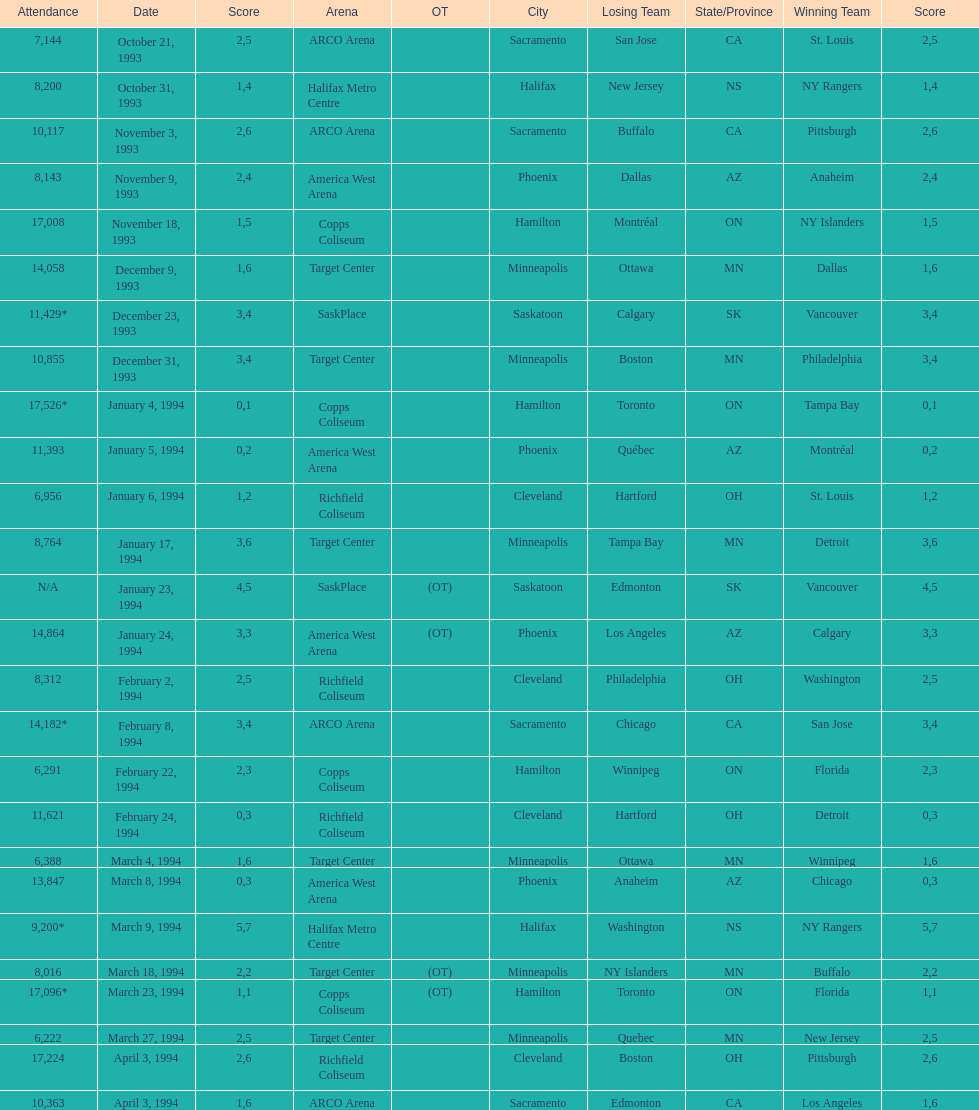Can you give me this table as a dict? {'header': ['Attendance', 'Date', 'Score', 'Arena', 'OT', 'City', 'Losing Team', 'State/Province', 'Winning Team', 'Score'], 'rows': [['7,144', 'October 21, 1993', '2', 'ARCO Arena', '', 'Sacramento', 'San Jose', 'CA', 'St. Louis', '5'], ['8,200', 'October 31, 1993', '1', 'Halifax Metro Centre', '', 'Halifax', 'New Jersey', 'NS', 'NY Rangers', '4'], ['10,117', 'November 3, 1993', '2', 'ARCO Arena', '', 'Sacramento', 'Buffalo', 'CA', 'Pittsburgh', '6'], ['8,143', 'November 9, 1993', '2', 'America West Arena', '', 'Phoenix', 'Dallas', 'AZ', 'Anaheim', '4'], ['17,008', 'November 18, 1993', '1', 'Copps Coliseum', '', 'Hamilton', 'Montréal', 'ON', 'NY Islanders', '5'], ['14,058', 'December 9, 1993', '1', 'Target Center', '', 'Minneapolis', 'Ottawa', 'MN', 'Dallas', '6'], ['11,429*', 'December 23, 1993', '3', 'SaskPlace', '', 'Saskatoon', 'Calgary', 'SK', 'Vancouver', '4'], ['10,855', 'December 31, 1993', '3', 'Target Center', '', 'Minneapolis', 'Boston', 'MN', 'Philadelphia', '4'], ['17,526*', 'January 4, 1994', '0', 'Copps Coliseum', '', 'Hamilton', 'Toronto', 'ON', 'Tampa Bay', '1'], ['11,393', 'January 5, 1994', '0', 'America West Arena', '', 'Phoenix', 'Québec', 'AZ', 'Montréal', '2'], ['6,956', 'January 6, 1994', '1', 'Richfield Coliseum', '', 'Cleveland', 'Hartford', 'OH', 'St. Louis', '2'], ['8,764', 'January 17, 1994', '3', 'Target Center', '', 'Minneapolis', 'Tampa Bay', 'MN', 'Detroit', '6'], ['N/A', 'January 23, 1994', '4', 'SaskPlace', '(OT)', 'Saskatoon', 'Edmonton', 'SK', 'Vancouver', '5'], ['14,864', 'January 24, 1994', '3', 'America West Arena', '(OT)', 'Phoenix', 'Los Angeles', 'AZ', 'Calgary', '3'], ['8,312', 'February 2, 1994', '2', 'Richfield Coliseum', '', 'Cleveland', 'Philadelphia', 'OH', 'Washington', '5'], ['14,182*', 'February 8, 1994', '3', 'ARCO Arena', '', 'Sacramento', 'Chicago', 'CA', 'San Jose', '4'], ['6,291', 'February 22, 1994', '2', 'Copps Coliseum', '', 'Hamilton', 'Winnipeg', 'ON', 'Florida', '3'], ['11,621', 'February 24, 1994', '0', 'Richfield Coliseum', '', 'Cleveland', 'Hartford', 'OH', 'Detroit', '3'], ['6,388', 'March 4, 1994', '1', 'Target Center', '', 'Minneapolis', 'Ottawa', 'MN', 'Winnipeg', '6'], ['13,847', 'March 8, 1994', '0', 'America West Arena', '', 'Phoenix', 'Anaheim', 'AZ', 'Chicago', '3'], ['9,200*', 'March 9, 1994', '5', 'Halifax Metro Centre', '', 'Halifax', 'Washington', 'NS', 'NY Rangers', '7'], ['8,016', 'March 18, 1994', '2', 'Target Center', '(OT)', 'Minneapolis', 'NY Islanders', 'MN', 'Buffalo', '2'], ['17,096*', 'March 23, 1994', '1', 'Copps Coliseum', '(OT)', 'Hamilton', 'Toronto', 'ON', 'Florida', '1'], ['6,222', 'March 27, 1994', '2', 'Target Center', '', 'Minneapolis', 'Quebec', 'MN', 'New Jersey', '5'], ['17,224', 'April 3, 1994', '2', 'Richfield Coliseum', '', 'Cleveland', 'Boston', 'OH', 'Pittsburgh', '6'], ['10,363', 'April 3, 1994', '1', 'ARCO Arena', '', 'Sacramento', 'Edmonton', 'CA', 'Los Angeles', '6']]} How many more people attended the november 18, 1993 games than the november 9th game? 8865. 